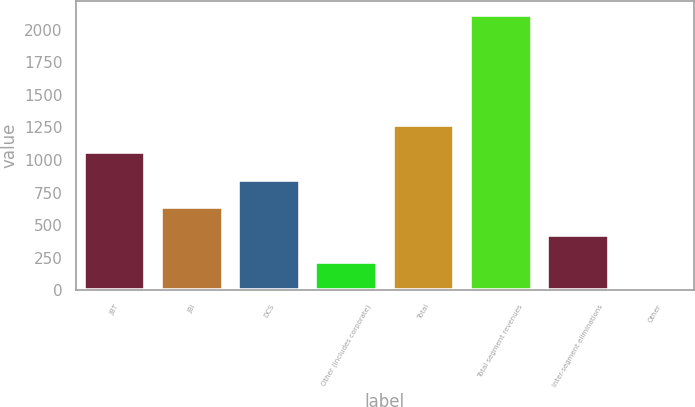Convert chart. <chart><loc_0><loc_0><loc_500><loc_500><bar_chart><fcel>JBT<fcel>JBI<fcel>DCS<fcel>Other (includes corporate)<fcel>Total<fcel>Total segment revenues<fcel>Inter-segment eliminations<fcel>Other<nl><fcel>1061<fcel>638.2<fcel>849.6<fcel>215.4<fcel>1272.4<fcel>2118<fcel>426.8<fcel>4<nl></chart> 